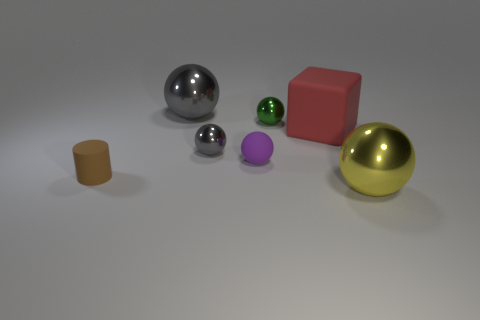Subtract all yellow balls. How many balls are left? 4 Subtract all small green balls. How many balls are left? 4 Subtract all blue balls. Subtract all cyan cubes. How many balls are left? 5 Add 3 small purple rubber cubes. How many objects exist? 10 Subtract all blocks. How many objects are left? 6 Subtract all large red rubber blocks. Subtract all small gray objects. How many objects are left? 5 Add 5 tiny green metallic objects. How many tiny green metallic objects are left? 6 Add 2 small gray shiny spheres. How many small gray shiny spheres exist? 3 Subtract 0 yellow cylinders. How many objects are left? 7 